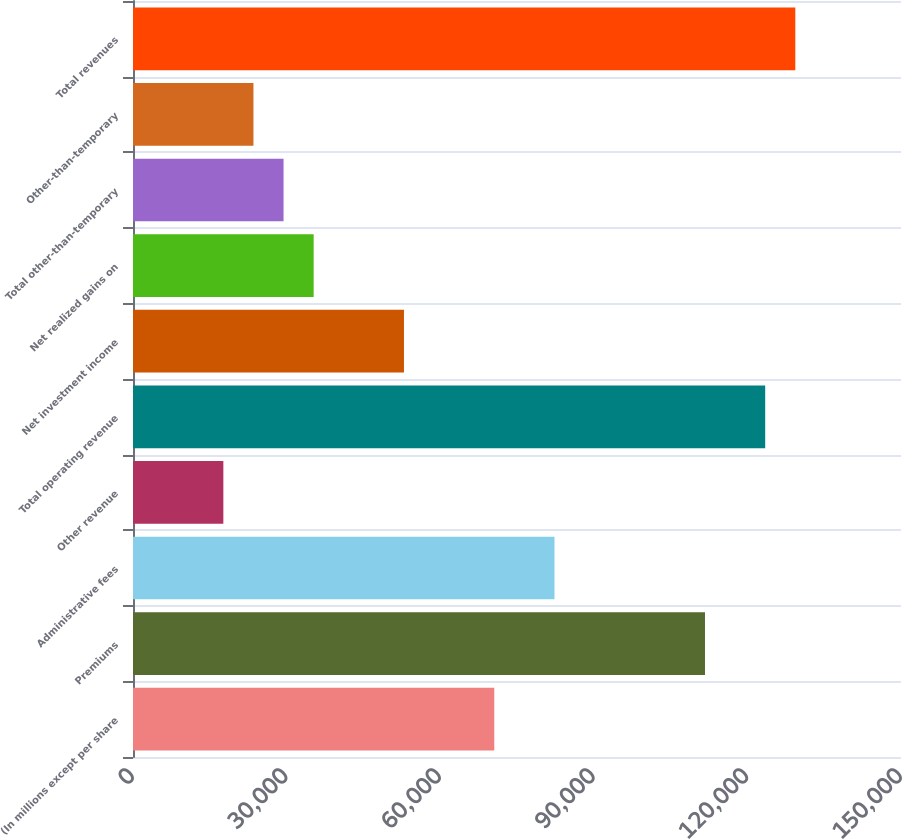<chart> <loc_0><loc_0><loc_500><loc_500><bar_chart><fcel>(In millions except per share<fcel>Premiums<fcel>Administrative fees<fcel>Other revenue<fcel>Total operating revenue<fcel>Net investment income<fcel>Net realized gains on<fcel>Total other-than-temporary<fcel>Other-than-temporary<fcel>Total revenues<nl><fcel>70560.8<fcel>111717<fcel>82319.8<fcel>17645.4<fcel>123476<fcel>52922.3<fcel>35283.9<fcel>29404.4<fcel>23524.9<fcel>129356<nl></chart> 